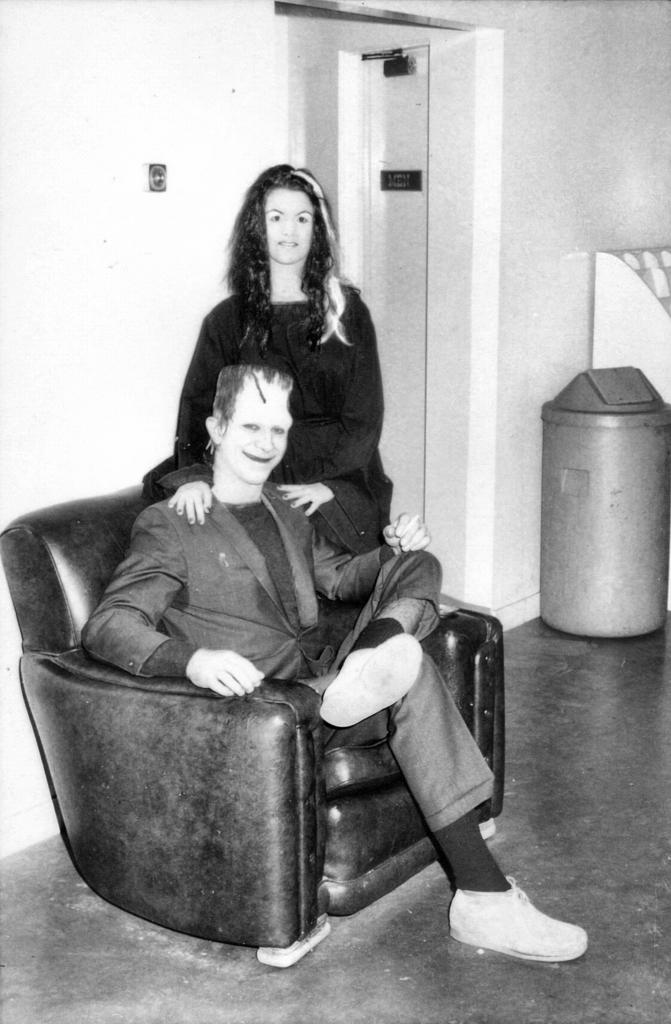How many people are in the image? There are two persons in the image. What is the position of one of the persons in the image? One person is sitting on a sofa. What is the position of the other person in the image? The other person is standing. What can be seen in the background of the image? There is a wall in the background of the image. What type of connection does the mom have with the person standing in the image? There is no mention of a mom in the image, so it is not possible to determine any connection between her and the person standing. 